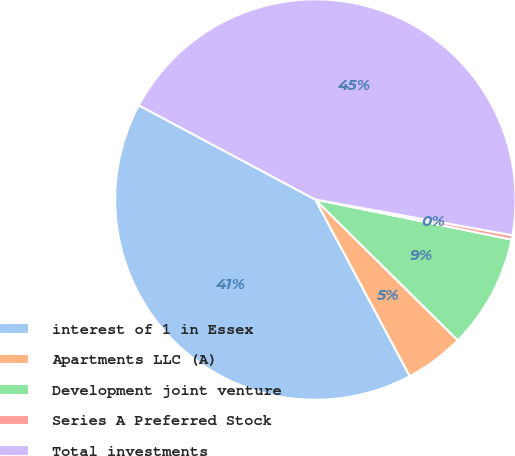Convert chart to OTSL. <chart><loc_0><loc_0><loc_500><loc_500><pie_chart><fcel>interest of 1 in Essex<fcel>Apartments LLC (A)<fcel>Development joint venture<fcel>Series A Preferred Stock<fcel>Total investments<nl><fcel>40.62%<fcel>4.78%<fcel>9.21%<fcel>0.35%<fcel>45.05%<nl></chart> 